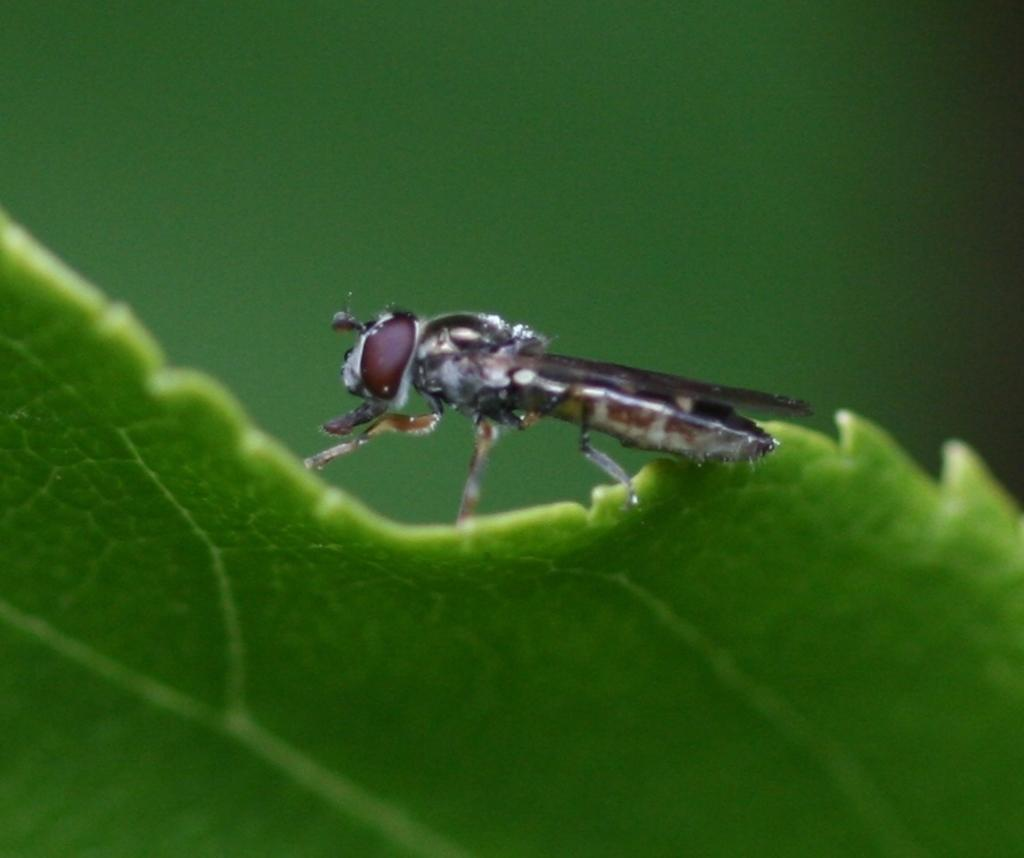What insect can be seen in the image? There is a bee in the image. What is the bee standing on? The bee is standing on a green leaf. Can you describe the background of the image? The background of the image is blurred. How many ladybugs are present on the green leaf in the image? There are no ladybugs present in the image; only a bee can be seen. What type of queen is visible in the image? There is no queen present in the image. 